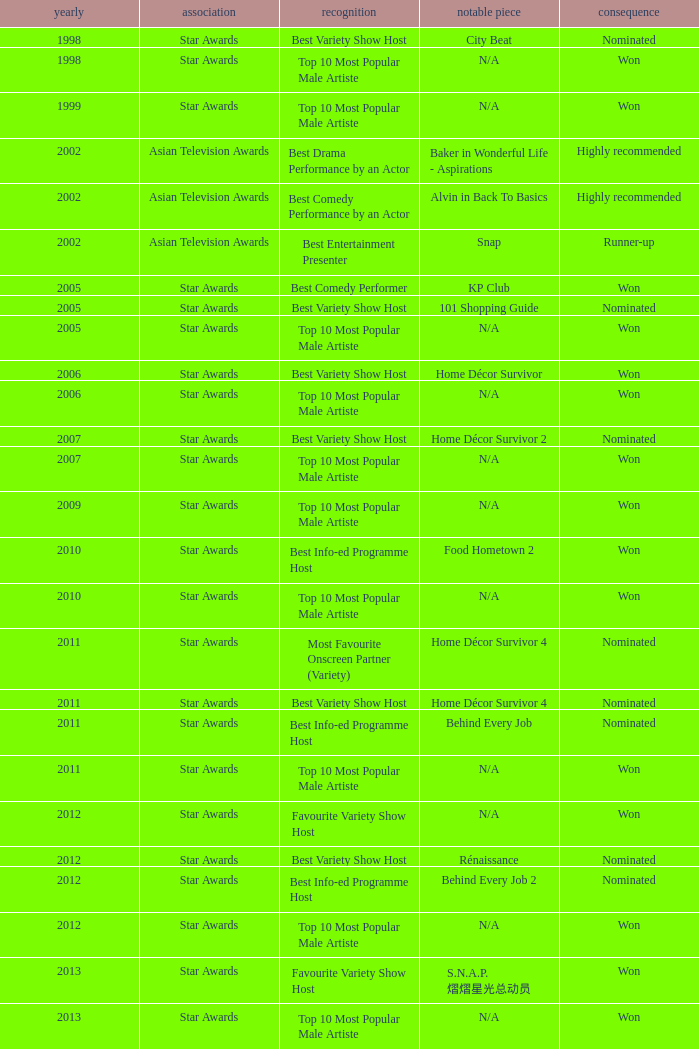What is the name of the Representative Work in a year later than 2005 with a Result of nominated, and an Award of best variety show host? Home Décor Survivor 2, Home Décor Survivor 4, Rénaissance, Jobs Around The World. 